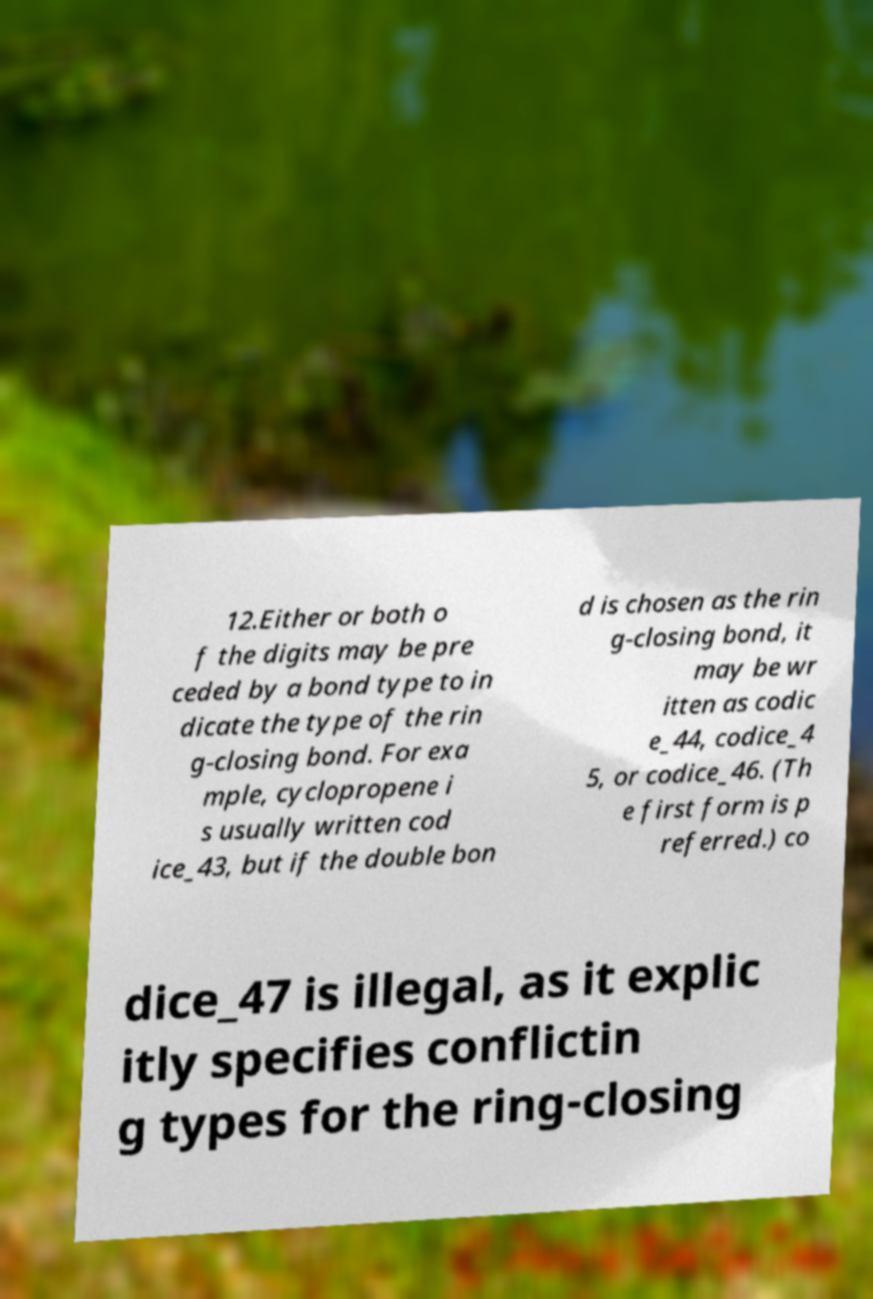Can you read and provide the text displayed in the image?This photo seems to have some interesting text. Can you extract and type it out for me? 12.Either or both o f the digits may be pre ceded by a bond type to in dicate the type of the rin g-closing bond. For exa mple, cyclopropene i s usually written cod ice_43, but if the double bon d is chosen as the rin g-closing bond, it may be wr itten as codic e_44, codice_4 5, or codice_46. (Th e first form is p referred.) co dice_47 is illegal, as it explic itly specifies conflictin g types for the ring-closing 